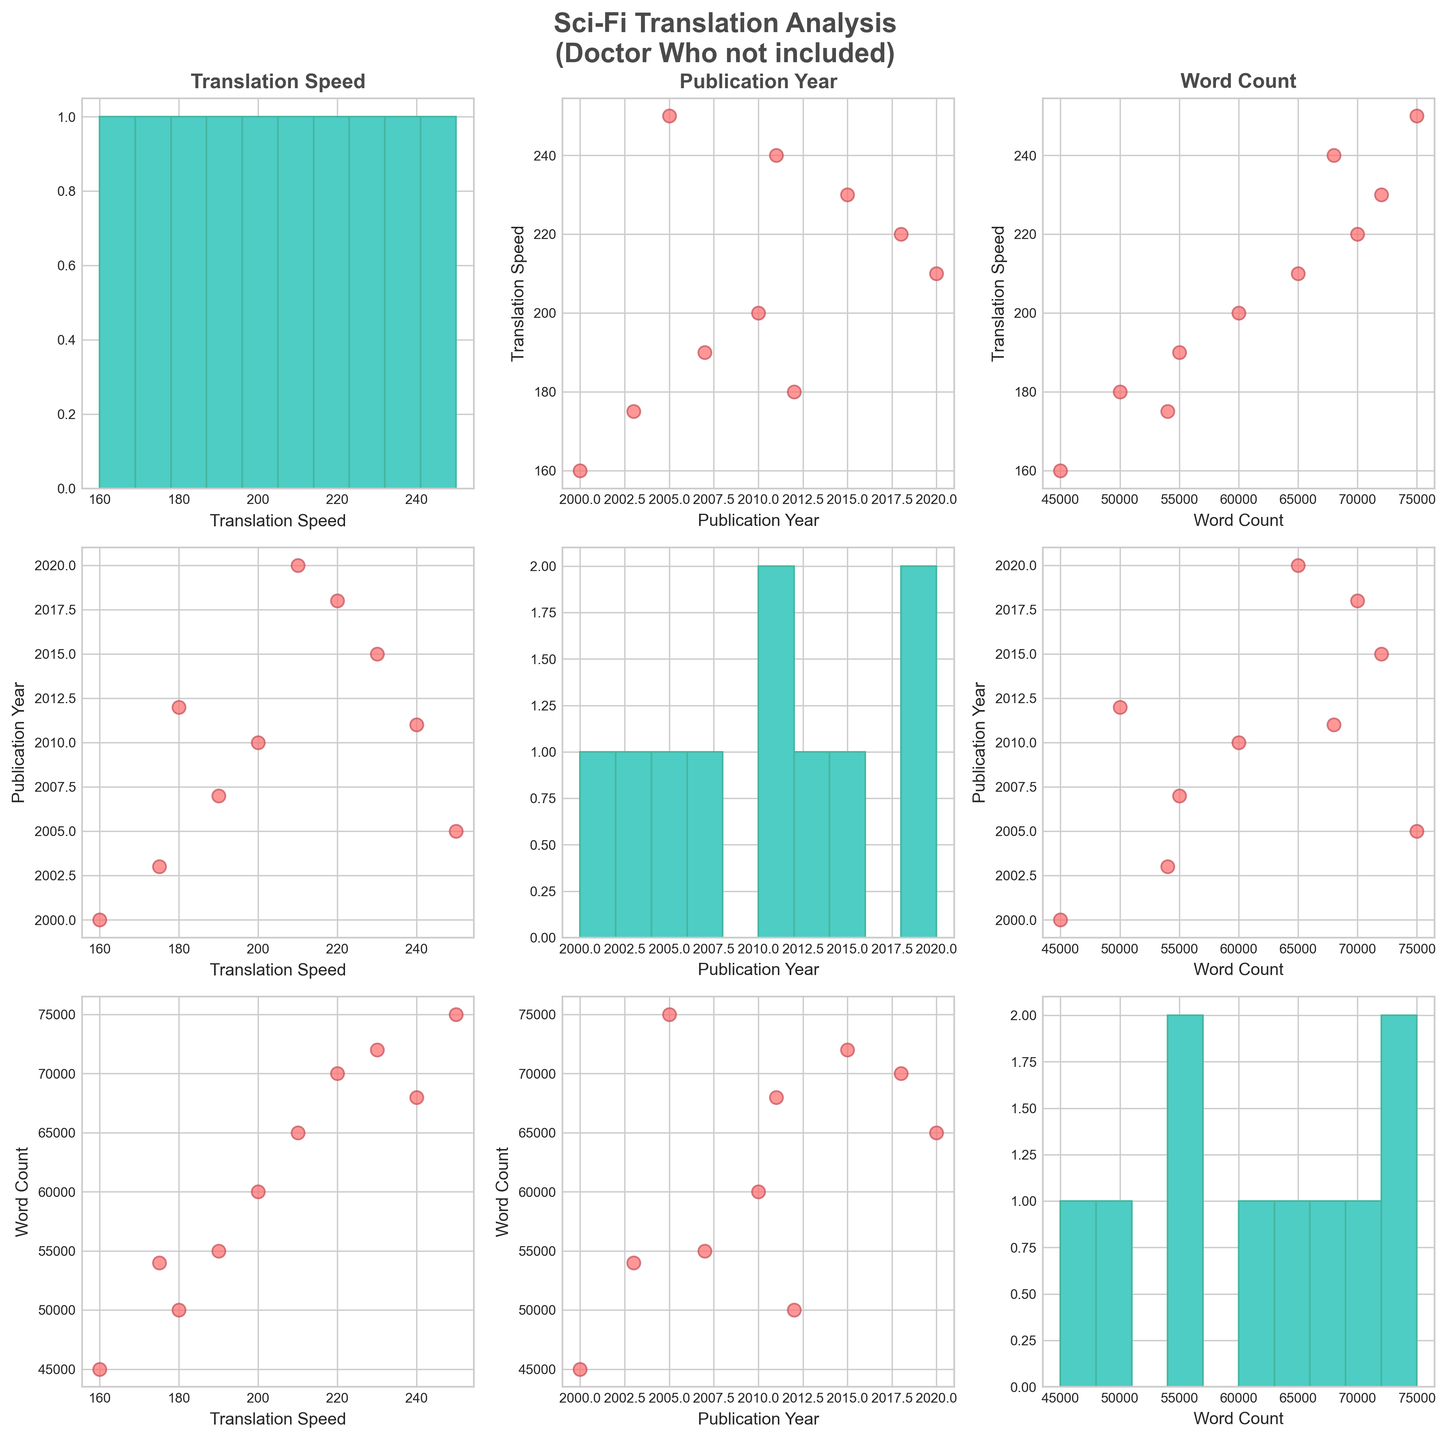What's the title of the figure? The title of the figure is displayed at the top of the plot. It reads "Sci-Fi Translation Analysis (Doctor Who not included)".
Answer: Sci-Fi Translation Analysis (Doctor Who not included) What is plotted on the x-axis of the scatter plot in the (1, 2) position? The x-axis of the scatter plot in the (1, 2) position is labeled "Word Count", which means it plots word count on the x-axis.
Answer: Word Count Which variable has the highest frequency in its histogram? By observing the histograms along the diagonal, we need to identify the variable with the tallest bar, representing the highest frequency. The histogram for the "Word Count" variable has the highest bar.
Answer: Word Count How does Translation Speed relate to Word Count? To determine the relationship between Translation Speed and Word Count, look at the scatter plot at the (2, 3) position. The general trend shows that as Word Count increases, Translation Speed generally increases as well, suggesting a positive correlation.
Answer: Positive correlation Which publication year has the most frequent occurrence in the data? By examining the histogram for the "Publication Year" variable, we look for the year with the tallest bar. The year 2010 seems to have the most frequent occurrences.
Answer: 2010 What is the general trend between Publication Year and Translation Speed? We should look at the scatter plot at the (1, 2) position. By examining this plot, we see that there is no clear linear trend as Publication Year increases on the x-axis; Translation Speeds appear scattered.
Answer: No clear trend Is there any outlier in the scatter plot of Word Count vs. Translation Speed? An outlier would be a point that doesn't follow the general pattern. By examining the scatter plot at the (2, 3) position, no clear outliers (significantly different values) are observed.
Answer: No What is the range of Word Count in the data? The range can be determined by looking at the minimum and maximum values in the "Word Count" histogram. The range of Word Count is from 45,000 to 75,000.
Answer: 45,000 to 75,000 